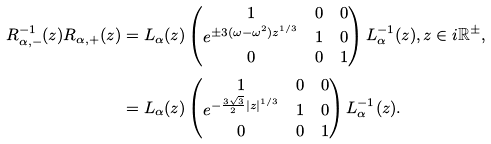Convert formula to latex. <formula><loc_0><loc_0><loc_500><loc_500>R _ { \alpha , - } ^ { - 1 } ( z ) R _ { \alpha , + } ( z ) & = L _ { \alpha } ( z ) \begin{pmatrix} 1 & 0 & 0 \\ e ^ { \pm 3 ( \omega - \omega ^ { 2 } ) z ^ { 1 / 3 } } & 1 & 0 \\ 0 & 0 & 1 \end{pmatrix} L _ { \alpha } ^ { - 1 } ( z ) , z \in i \mathbb { R } ^ { \pm } , \\ & = L _ { \alpha } ( z ) \begin{pmatrix} 1 & 0 & 0 \\ e ^ { - \frac { 3 \sqrt { 3 } } { 2 } | z | ^ { 1 / 3 } } & 1 & 0 \\ 0 & 0 & 1 \end{pmatrix} L _ { \alpha } ^ { - 1 } ( z ) .</formula> 